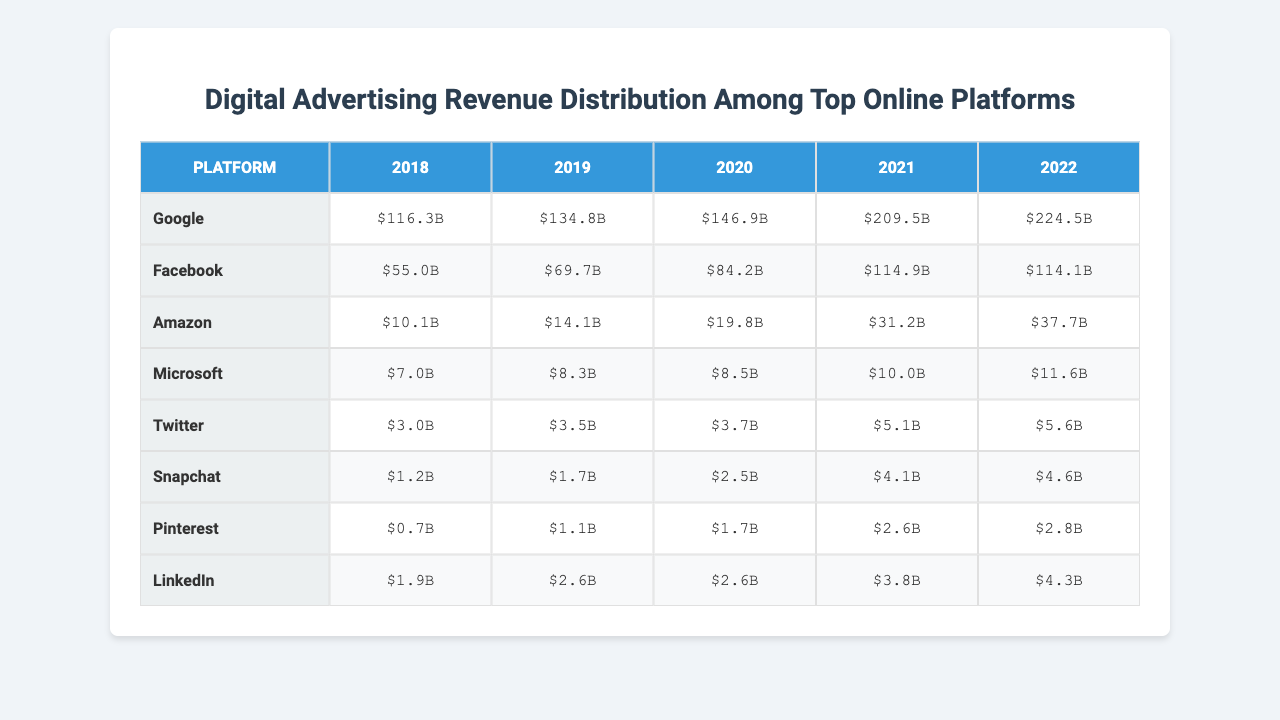What was Google's advertising revenue in 2021? In the table, we can find Google's revenue data for 2021, which is listed under the corresponding year. The revenue for Google in 2021 is $209.5 billion.
Answer: $209.5 billion Which platform had the highest revenue in 2022? By examining the last column of the table for the year 2022, we see that Google has the highest revenue at $224.5 billion, compared to other platforms.
Answer: Google What was the total advertising revenue for Facebook from 2018 to 2022? To find the total revenue for Facebook over these years, we sum the values from the table: 55.0 + 69.7 + 84.2 + 114.9 + 114.1 = 438.0 billion.
Answer: $438.0 billion Did Amazon's revenue surpass that of Twitter in 2020? In the table, we identify Amazon's revenue for 2020 as $19.8 billion and Twitter's as $3.7 billion. Since $19.8 billion is greater than $3.7 billion, Amazon's revenue did surpass Twitter’s.
Answer: Yes What is the average revenue of LinkedIn over the years provided? The revenue for LinkedIn from 2018 to 2022 is: 1.9 + 2.6 + 2.6 + 3.8 + 4.3. Calculating the total gives us 15.2 billion, and dividing by 5 (the number of years) results in an average of 3.04 billion.
Answer: $3.04 billion What is the percentage growth of Snap's revenue from 2018 to 2022? We first find the revenues for Snap in both years: 2018 is $1.2 billion, and 2022 is $4.6 billion. The growth is calculated as ((4.6 - 1.2) / 1.2) * 100 = 283.33%.
Answer: 283.33% Which platform had the lowest revenue in 2019? Looking at the table for 2019, we find the revenues: Google $69.7 billion, Facebook $14.1 billion, Amazon $1.7 billion, Microsoft $8.3 billion, Twitter $3.5 billion, Snapchat $1.2 billion, Pinterest $1.1 billion, LinkedIn $2.6 billion. The platform with the lowest revenue is Snapchat at $1.7 billion.
Answer: Snapchat What is the difference in revenue between Microsoft in 2022 and Twitter in 2022? For Microsoft in 2022, the revenue is $11.6 billion, and for Twitter, it is $5.6 billion. The difference is calculated as 11.6 - 5.6 = 6.0 billion.
Answer: $6.0 billion Is there a trend of increasing revenue for Amazon from 2018 to 2022? By analyzing the data points for Amazon from 2018 ($10.1 billion) to 2022 ($37.7 billion), we observe a steady increase in revenue every year indicating a clear trend of growth.
Answer: Yes What was the revenue for the platform ranked second in 2021? In 2021, the platforms sorted by revenue are Google, Facebook, Amazon, Microsoft, and others. The second highest revenue is Facebook at $114.9 billion.
Answer: Facebook 